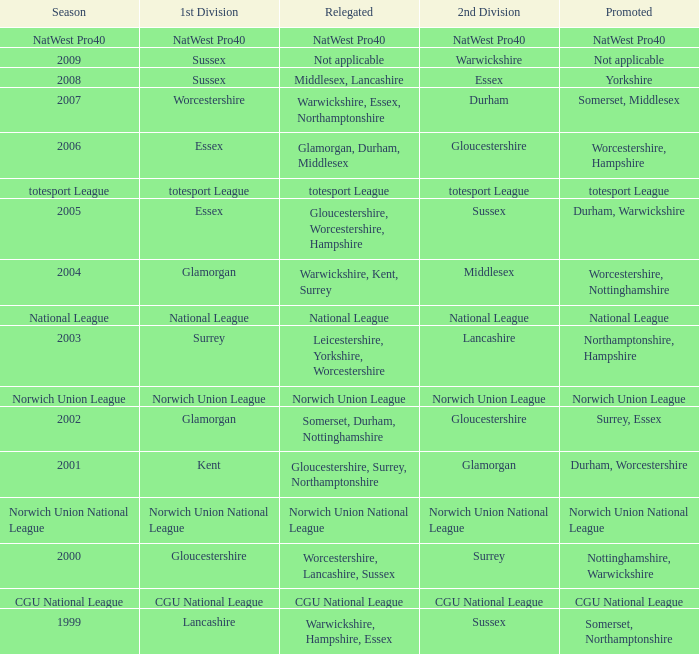What is the 1st division when the 2nd division is national league? National League. 